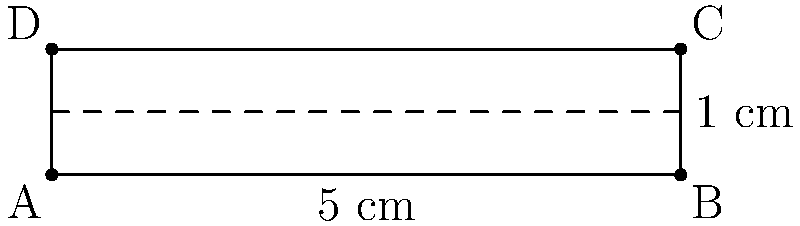A scaled diagram of a stick insect is shown above. If the actual length of the stick insect is 10 cm, what is the scale factor of the diagram? To find the scale factor, we need to compare the length in the diagram to the actual length of the stick insect. Let's follow these steps:

1) In the diagram, the length of the stick insect is represented by the line AB.
2) The length of AB in the diagram is 5 cm (as labeled).
3) We're told that the actual length of the stick insect is 10 cm.
4) The scale factor is the ratio of the diagram length to the actual length:

   $\text{Scale factor} = \frac{\text{Diagram length}}{\text{Actual length}}$

5) Substituting the values:

   $\text{Scale factor} = \frac{5 \text{ cm}}{10 \text{ cm}} = \frac{1}{2} = 0.5$

Therefore, the scale factor of the diagram is 0.5 or 1:2.
Answer: 0.5 